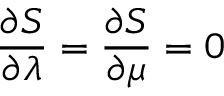Convert formula to latex. <formula><loc_0><loc_0><loc_500><loc_500>\frac { \partial S } { \partial \lambda } = \frac { \partial S } { \partial \mu } = 0</formula> 